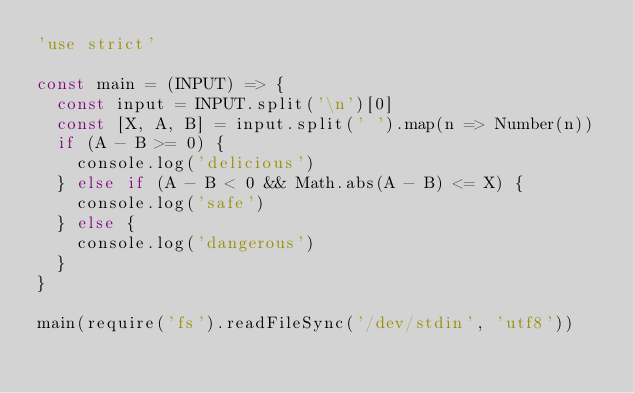Convert code to text. <code><loc_0><loc_0><loc_500><loc_500><_JavaScript_>'use strict'

const main = (INPUT) => {
  const input = INPUT.split('\n')[0]
  const [X, A, B] = input.split(' ').map(n => Number(n))
  if (A - B >= 0) {
    console.log('delicious')
  } else if (A - B < 0 && Math.abs(A - B) <= X) {
    console.log('safe')
  } else {
    console.log('dangerous')
  }
}

main(require('fs').readFileSync('/dev/stdin', 'utf8'))
</code> 